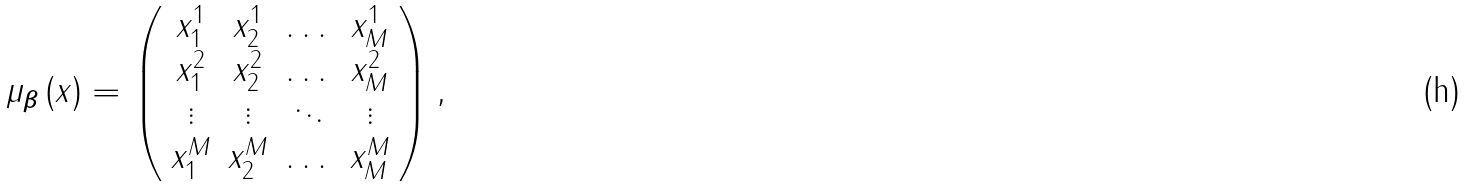Convert formula to latex. <formula><loc_0><loc_0><loc_500><loc_500>\mu _ { \boldsymbol \beta } \left ( x \right ) = \left ( \begin{array} { c c c c } x ^ { 1 } _ { 1 } & x ^ { 1 } _ { 2 } & \dots & x ^ { 1 } _ { M } \\ x ^ { 2 } _ { 1 } & x ^ { 2 } _ { 2 } & \dots & x ^ { 2 } _ { M } \\ \vdots & \vdots & \ddots & \vdots \\ x ^ { M } _ { 1 } & x ^ { M } _ { 2 } & \dots & x ^ { M } _ { M } \\ \end{array} \right ) ,</formula> 